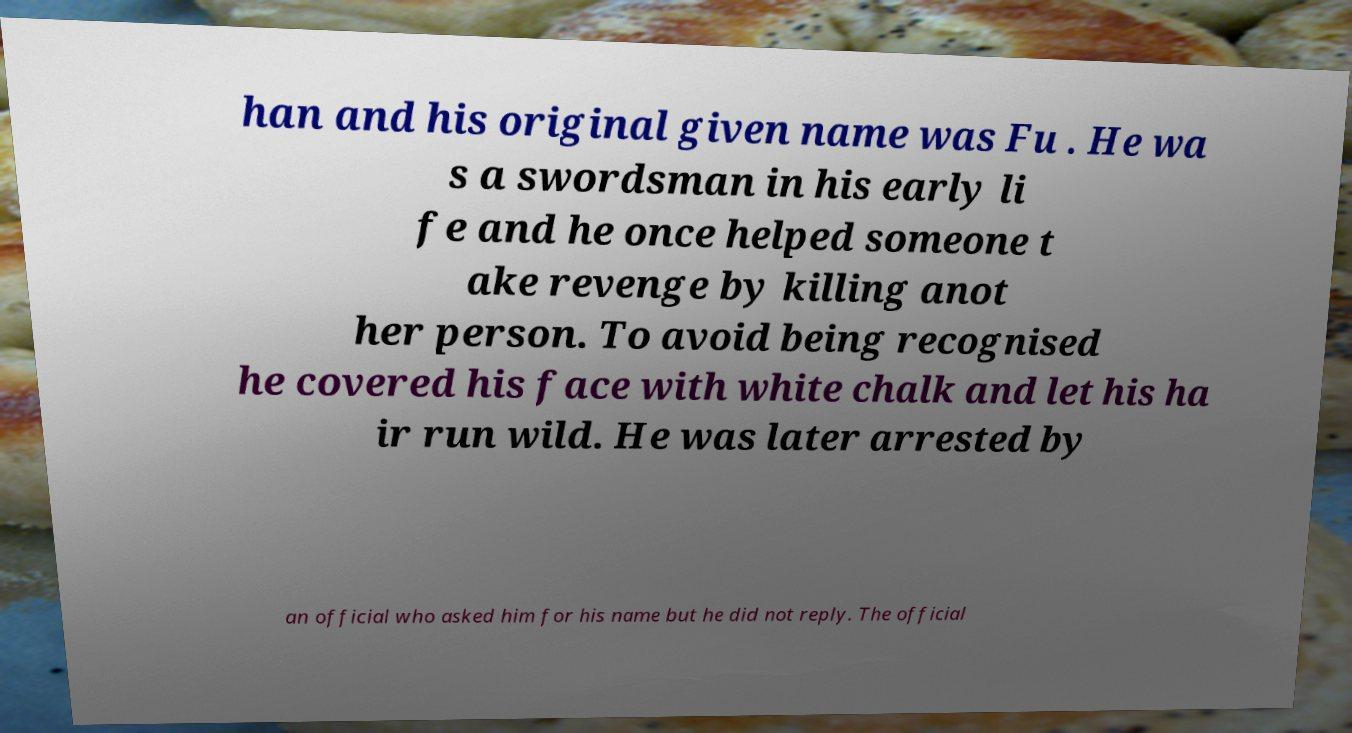Please read and relay the text visible in this image. What does it say? han and his original given name was Fu . He wa s a swordsman in his early li fe and he once helped someone t ake revenge by killing anot her person. To avoid being recognised he covered his face with white chalk and let his ha ir run wild. He was later arrested by an official who asked him for his name but he did not reply. The official 